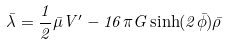<formula> <loc_0><loc_0><loc_500><loc_500>\bar { \lambda } = \frac { 1 } { 2 } \bar { \mu } V ^ { \prime } - 1 6 \pi G \sinh ( 2 \bar { \phi } ) \bar { \rho }</formula> 